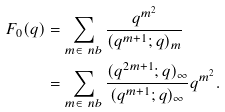Convert formula to latex. <formula><loc_0><loc_0><loc_500><loc_500>F _ { 0 } ( q ) & = \sum _ { m \in \ n b } \frac { q ^ { m ^ { 2 } } } { ( q ^ { m + 1 } ; q ) _ { m } } \\ & = \sum _ { m \in \ n b } \frac { ( q ^ { 2 m + 1 } ; q ) _ { \infty } } { ( q ^ { m + 1 } ; q ) _ { \infty } } q ^ { m ^ { 2 } } .</formula> 